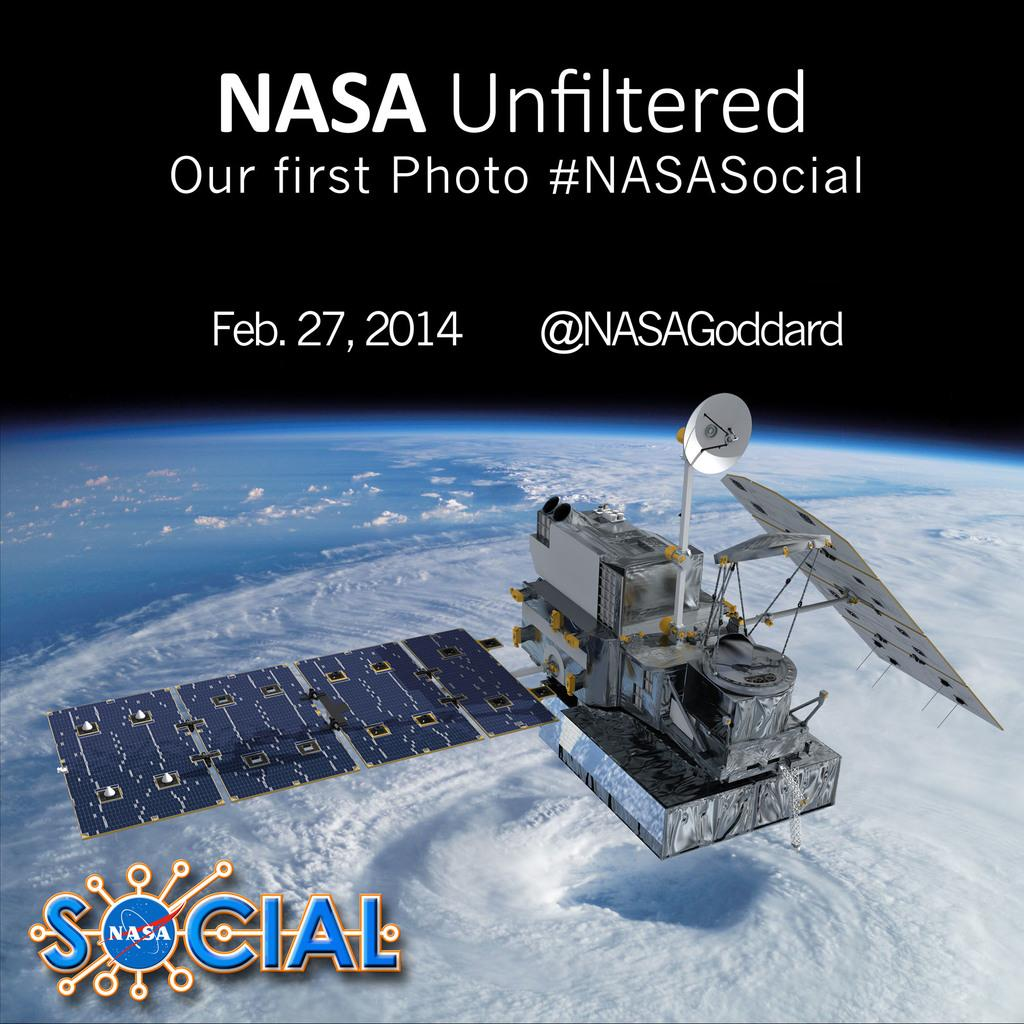What is the main subject of the image? The main subject of the image is a satellite. Where is the satellite located in relation to the Earth? The satellite is above the Earth. What can be seen at the top and bottom of the image? There is text at the top and bottom of the image. What type of plate is being used by the satellite's brother in the image? There is no plate or brother present in the image, as it features a satellite above the Earth with text at the top and bottom. 